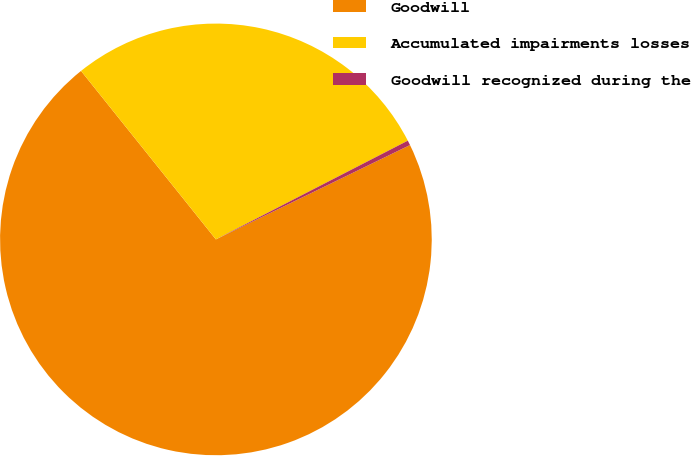Convert chart to OTSL. <chart><loc_0><loc_0><loc_500><loc_500><pie_chart><fcel>Goodwill<fcel>Accumulated impairments losses<fcel>Goodwill recognized during the<nl><fcel>71.45%<fcel>28.18%<fcel>0.36%<nl></chart> 